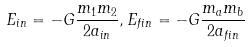Convert formula to latex. <formula><loc_0><loc_0><loc_500><loc_500>E _ { i n } = - G \frac { m _ { 1 } m _ { 2 } } { 2 a _ { i n } } , E _ { f i n } = - G \frac { m _ { a } m _ { b } } { 2 a _ { f i n } }</formula> 